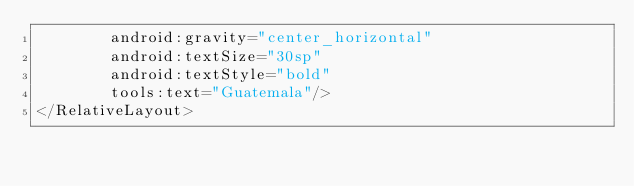<code> <loc_0><loc_0><loc_500><loc_500><_XML_>        android:gravity="center_horizontal"
        android:textSize="30sp"
        android:textStyle="bold"
        tools:text="Guatemala"/>
</RelativeLayout>
</code> 